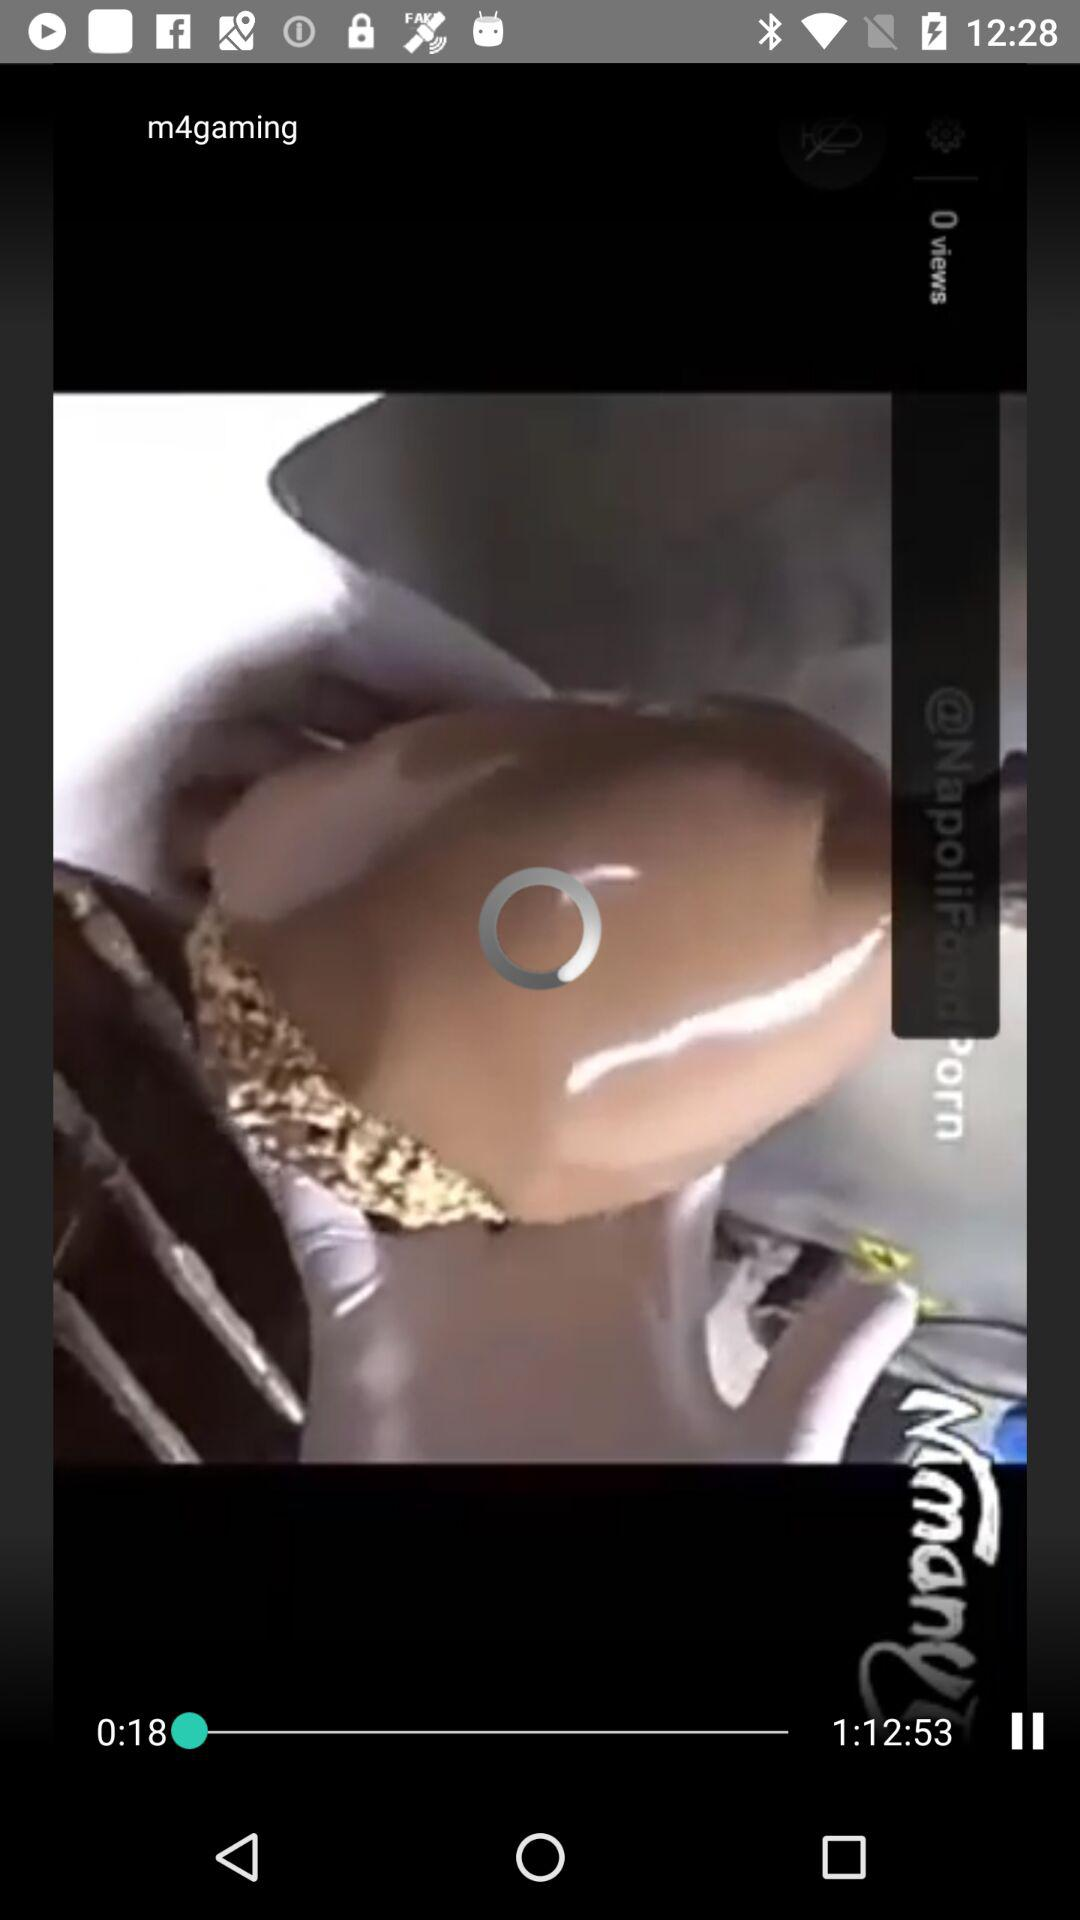How much video has been played? The video has been played for 18 seconds. 